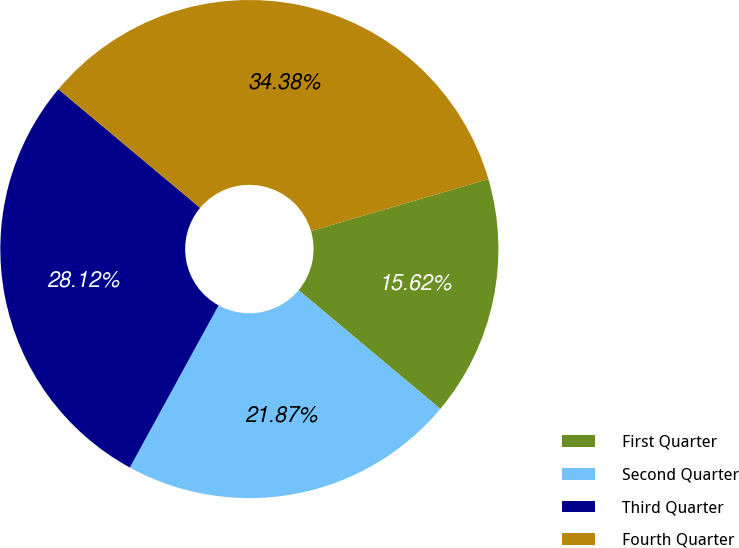<chart> <loc_0><loc_0><loc_500><loc_500><pie_chart><fcel>First Quarter<fcel>Second Quarter<fcel>Third Quarter<fcel>Fourth Quarter<nl><fcel>15.62%<fcel>21.87%<fcel>28.12%<fcel>34.38%<nl></chart> 